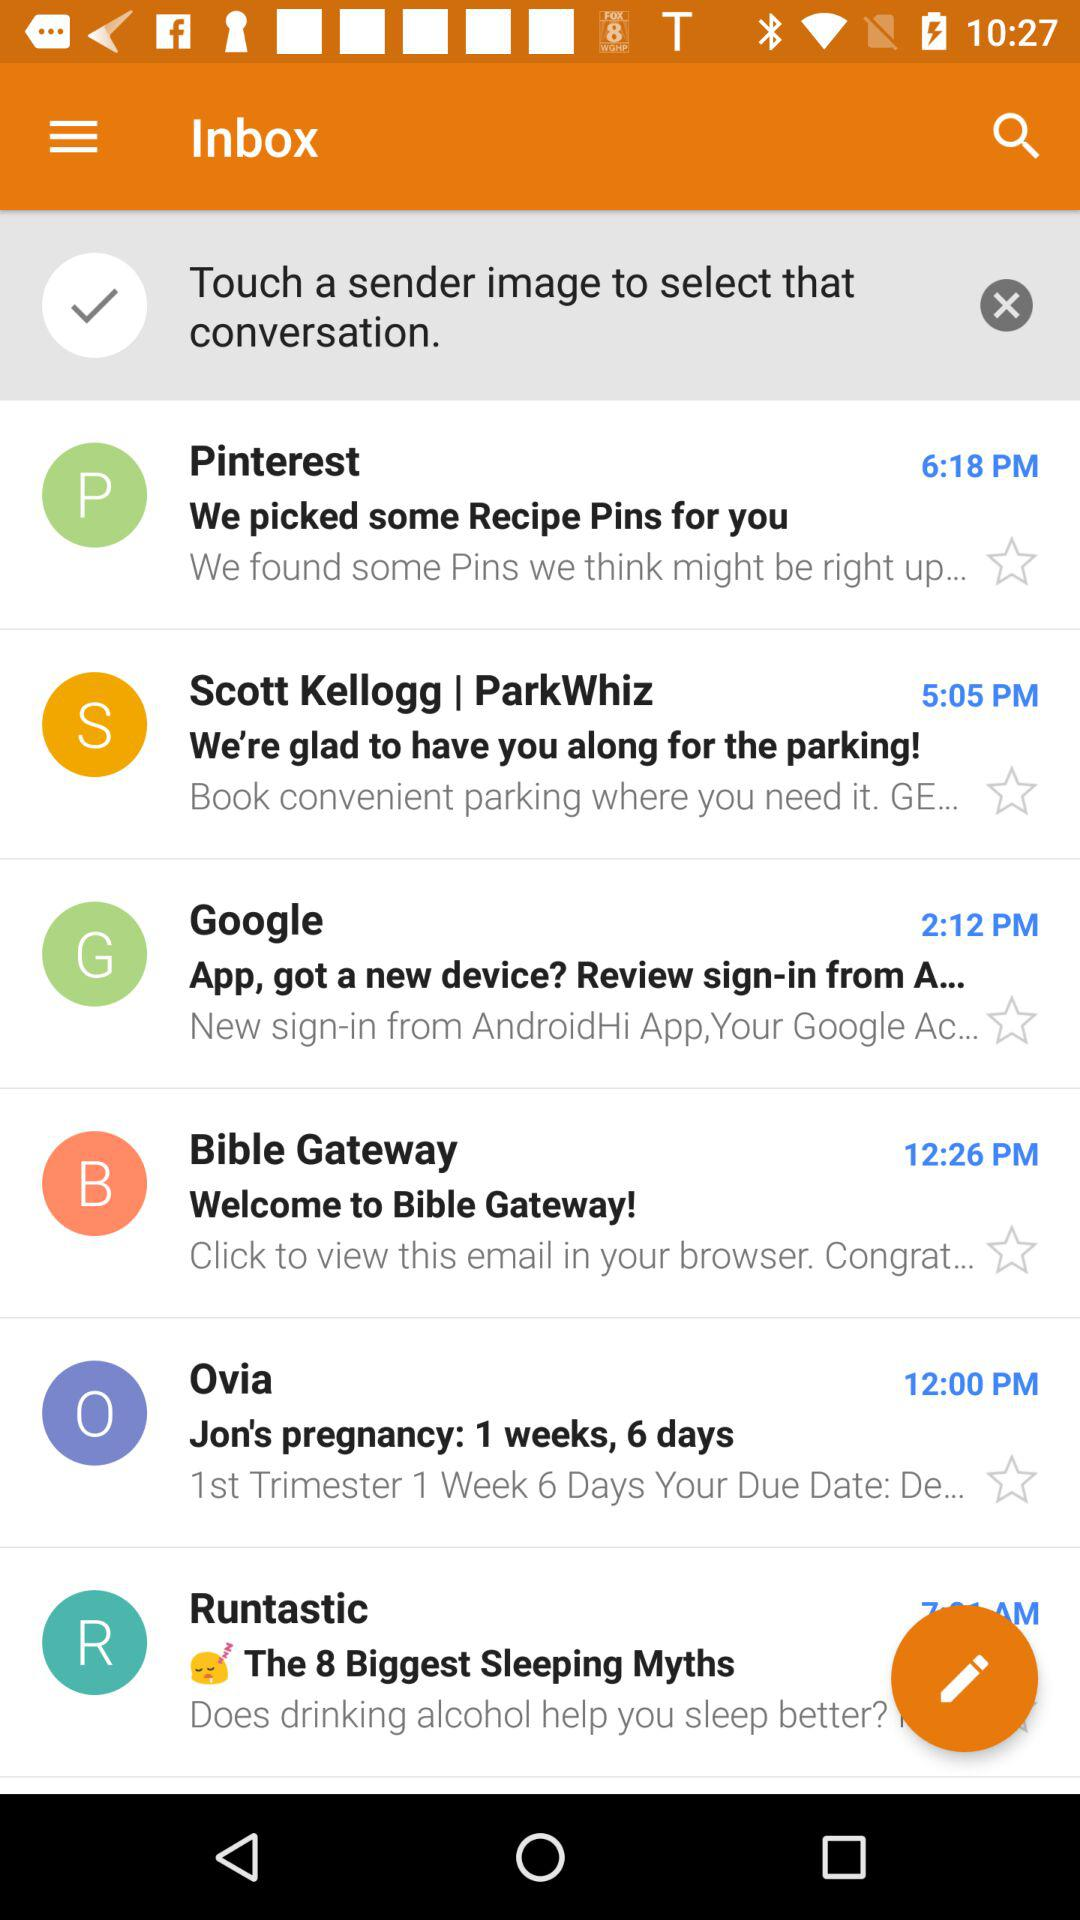When was the email by "Google" received? The email was received at 2:12 PM. 